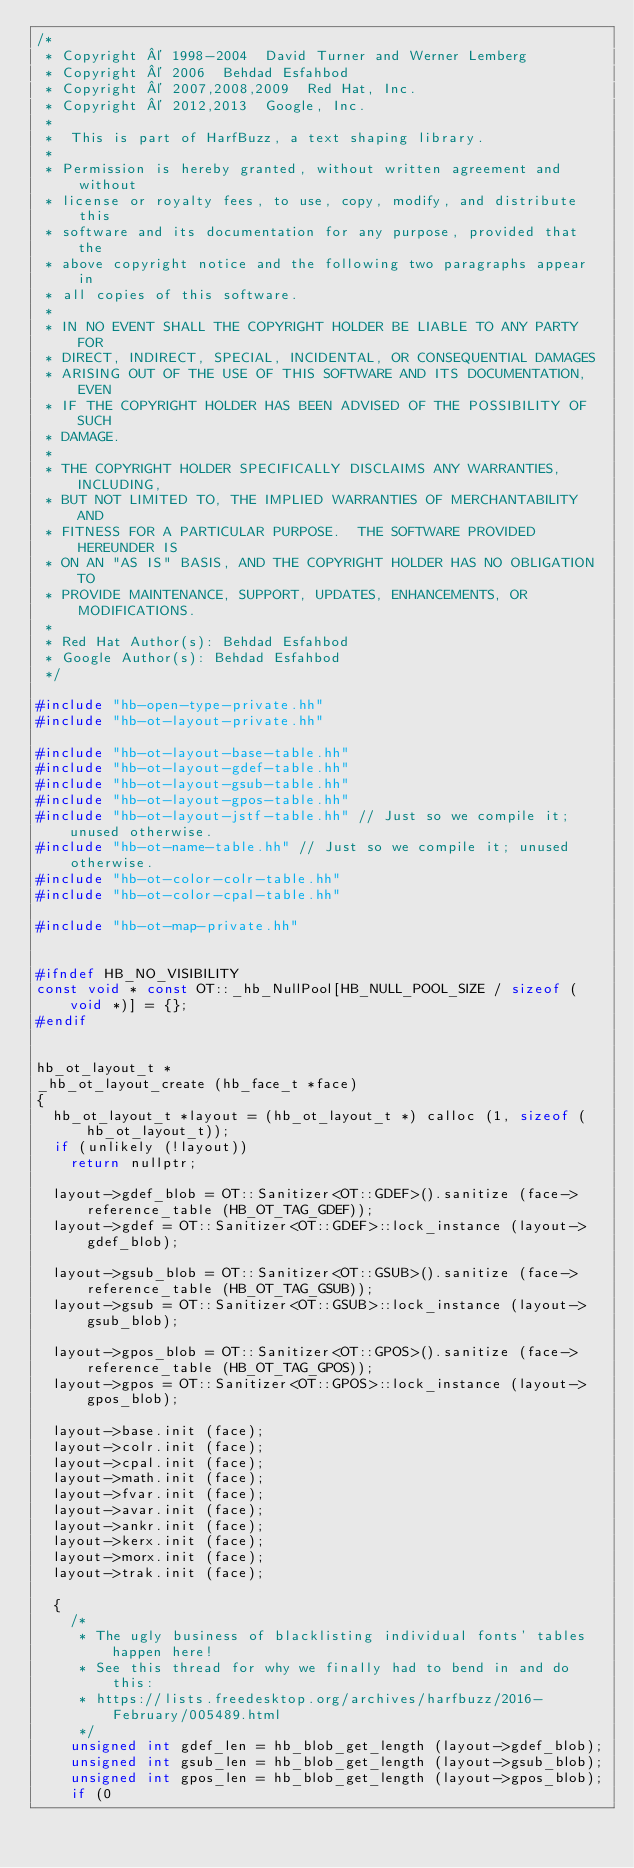Convert code to text. <code><loc_0><loc_0><loc_500><loc_500><_C++_>/*
 * Copyright © 1998-2004  David Turner and Werner Lemberg
 * Copyright © 2006  Behdad Esfahbod
 * Copyright © 2007,2008,2009  Red Hat, Inc.
 * Copyright © 2012,2013  Google, Inc.
 *
 *  This is part of HarfBuzz, a text shaping library.
 *
 * Permission is hereby granted, without written agreement and without
 * license or royalty fees, to use, copy, modify, and distribute this
 * software and its documentation for any purpose, provided that the
 * above copyright notice and the following two paragraphs appear in
 * all copies of this software.
 *
 * IN NO EVENT SHALL THE COPYRIGHT HOLDER BE LIABLE TO ANY PARTY FOR
 * DIRECT, INDIRECT, SPECIAL, INCIDENTAL, OR CONSEQUENTIAL DAMAGES
 * ARISING OUT OF THE USE OF THIS SOFTWARE AND ITS DOCUMENTATION, EVEN
 * IF THE COPYRIGHT HOLDER HAS BEEN ADVISED OF THE POSSIBILITY OF SUCH
 * DAMAGE.
 *
 * THE COPYRIGHT HOLDER SPECIFICALLY DISCLAIMS ANY WARRANTIES, INCLUDING,
 * BUT NOT LIMITED TO, THE IMPLIED WARRANTIES OF MERCHANTABILITY AND
 * FITNESS FOR A PARTICULAR PURPOSE.  THE SOFTWARE PROVIDED HEREUNDER IS
 * ON AN "AS IS" BASIS, AND THE COPYRIGHT HOLDER HAS NO OBLIGATION TO
 * PROVIDE MAINTENANCE, SUPPORT, UPDATES, ENHANCEMENTS, OR MODIFICATIONS.
 *
 * Red Hat Author(s): Behdad Esfahbod
 * Google Author(s): Behdad Esfahbod
 */

#include "hb-open-type-private.hh"
#include "hb-ot-layout-private.hh"

#include "hb-ot-layout-base-table.hh"
#include "hb-ot-layout-gdef-table.hh"
#include "hb-ot-layout-gsub-table.hh"
#include "hb-ot-layout-gpos-table.hh"
#include "hb-ot-layout-jstf-table.hh" // Just so we compile it; unused otherwise.
#include "hb-ot-name-table.hh" // Just so we compile it; unused otherwise.
#include "hb-ot-color-colr-table.hh"
#include "hb-ot-color-cpal-table.hh"

#include "hb-ot-map-private.hh"


#ifndef HB_NO_VISIBILITY
const void * const OT::_hb_NullPool[HB_NULL_POOL_SIZE / sizeof (void *)] = {};
#endif


hb_ot_layout_t *
_hb_ot_layout_create (hb_face_t *face)
{
  hb_ot_layout_t *layout = (hb_ot_layout_t *) calloc (1, sizeof (hb_ot_layout_t));
  if (unlikely (!layout))
    return nullptr;

  layout->gdef_blob = OT::Sanitizer<OT::GDEF>().sanitize (face->reference_table (HB_OT_TAG_GDEF));
  layout->gdef = OT::Sanitizer<OT::GDEF>::lock_instance (layout->gdef_blob);

  layout->gsub_blob = OT::Sanitizer<OT::GSUB>().sanitize (face->reference_table (HB_OT_TAG_GSUB));
  layout->gsub = OT::Sanitizer<OT::GSUB>::lock_instance (layout->gsub_blob);

  layout->gpos_blob = OT::Sanitizer<OT::GPOS>().sanitize (face->reference_table (HB_OT_TAG_GPOS));
  layout->gpos = OT::Sanitizer<OT::GPOS>::lock_instance (layout->gpos_blob);

  layout->base.init (face);
  layout->colr.init (face);
  layout->cpal.init (face);
  layout->math.init (face);
  layout->fvar.init (face);
  layout->avar.init (face);
  layout->ankr.init (face);
  layout->kerx.init (face);
  layout->morx.init (face);
  layout->trak.init (face);

  {
    /*
     * The ugly business of blacklisting individual fonts' tables happen here!
     * See this thread for why we finally had to bend in and do this:
     * https://lists.freedesktop.org/archives/harfbuzz/2016-February/005489.html
     */
    unsigned int gdef_len = hb_blob_get_length (layout->gdef_blob);
    unsigned int gsub_len = hb_blob_get_length (layout->gsub_blob);
    unsigned int gpos_len = hb_blob_get_length (layout->gpos_blob);
    if (0</code> 